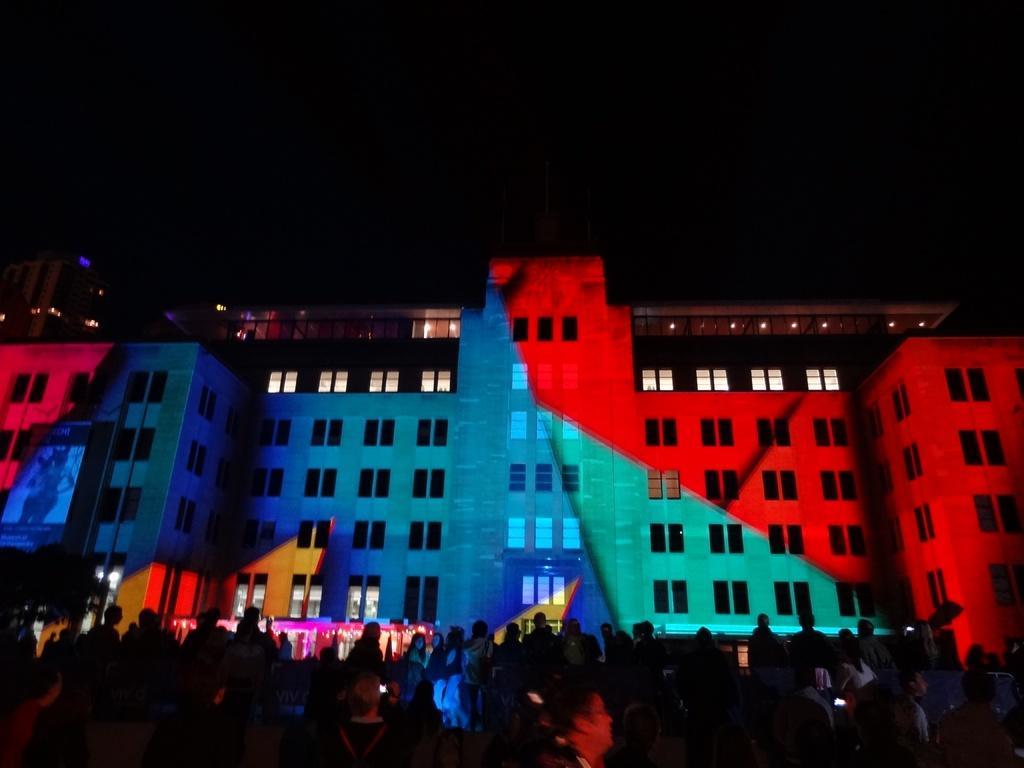How would you summarize this image in a sentence or two? In this image in the center there are buildings, and on the buildings there are some colors. At the bottom of the image there are some people and some lights, and the top of the image is dark. 